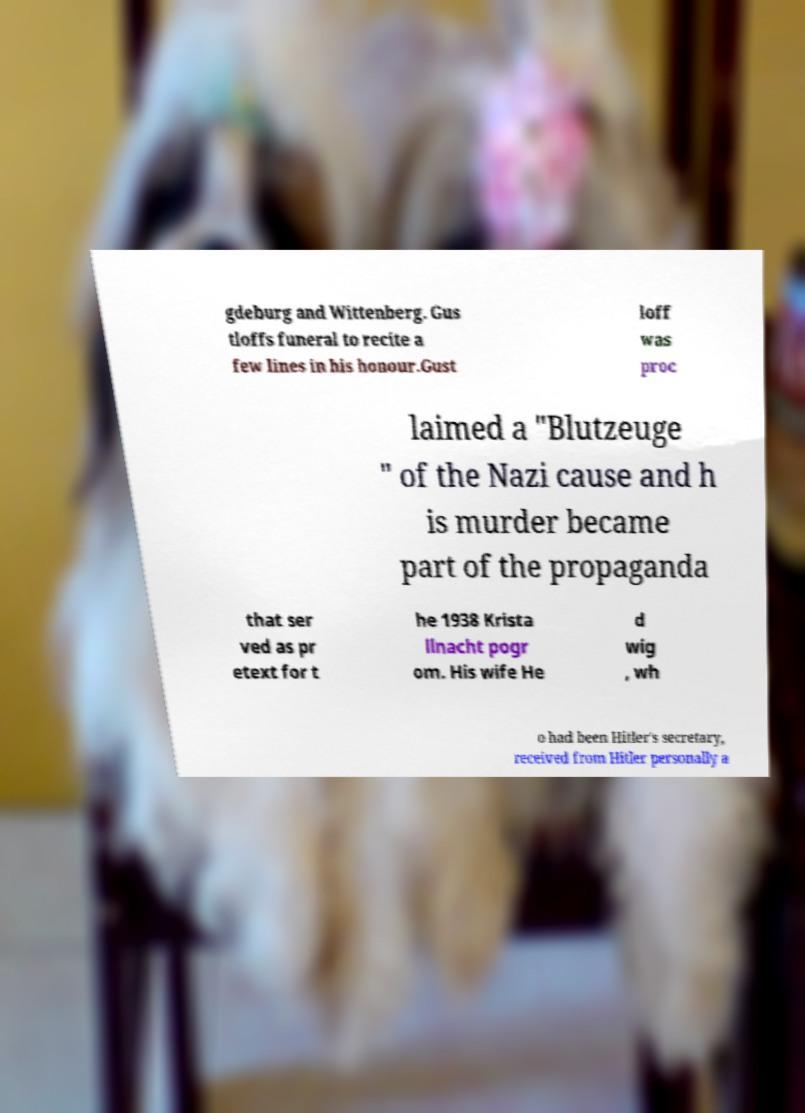Can you read and provide the text displayed in the image?This photo seems to have some interesting text. Can you extract and type it out for me? gdeburg and Wittenberg. Gus tloffs funeral to recite a few lines in his honour.Gust loff was proc laimed a "Blutzeuge " of the Nazi cause and h is murder became part of the propaganda that ser ved as pr etext for t he 1938 Krista llnacht pogr om. His wife He d wig , wh o had been Hitler's secretary, received from Hitler personally a 